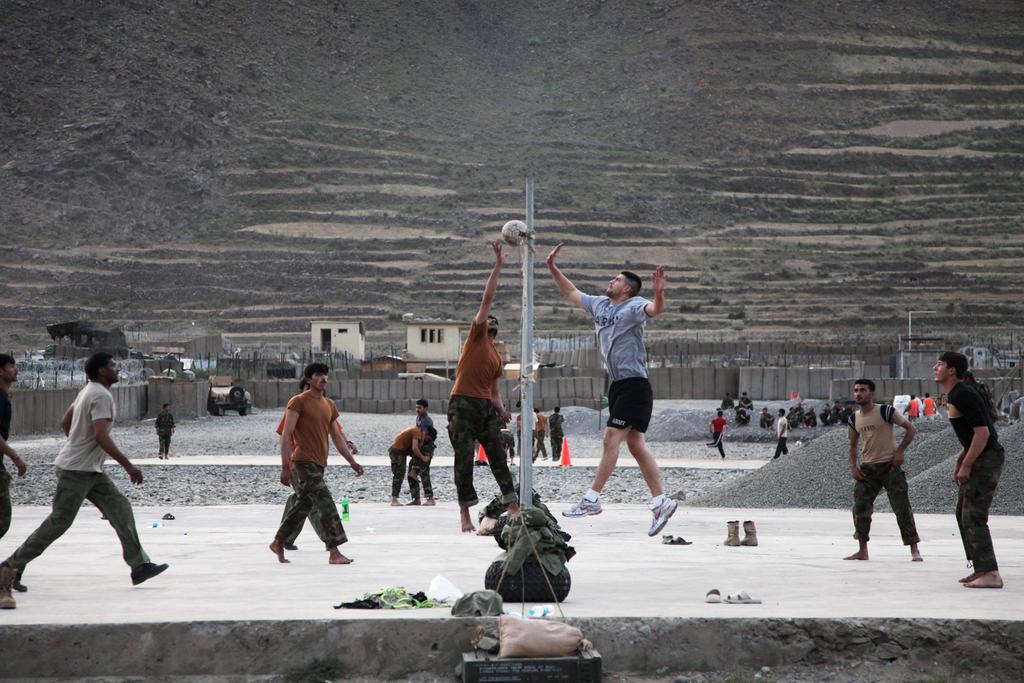Please provide a concise description of this image. In the image few people are standing and walking and jumping. Behind them there are some poles and fencing and houses and bottles and shoe. At the top of the image there is a hill. 